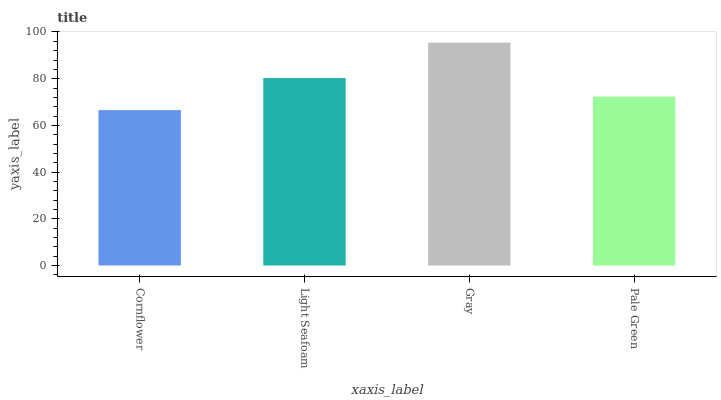Is Cornflower the minimum?
Answer yes or no. Yes. Is Gray the maximum?
Answer yes or no. Yes. Is Light Seafoam the minimum?
Answer yes or no. No. Is Light Seafoam the maximum?
Answer yes or no. No. Is Light Seafoam greater than Cornflower?
Answer yes or no. Yes. Is Cornflower less than Light Seafoam?
Answer yes or no. Yes. Is Cornflower greater than Light Seafoam?
Answer yes or no. No. Is Light Seafoam less than Cornflower?
Answer yes or no. No. Is Light Seafoam the high median?
Answer yes or no. Yes. Is Pale Green the low median?
Answer yes or no. Yes. Is Pale Green the high median?
Answer yes or no. No. Is Gray the low median?
Answer yes or no. No. 